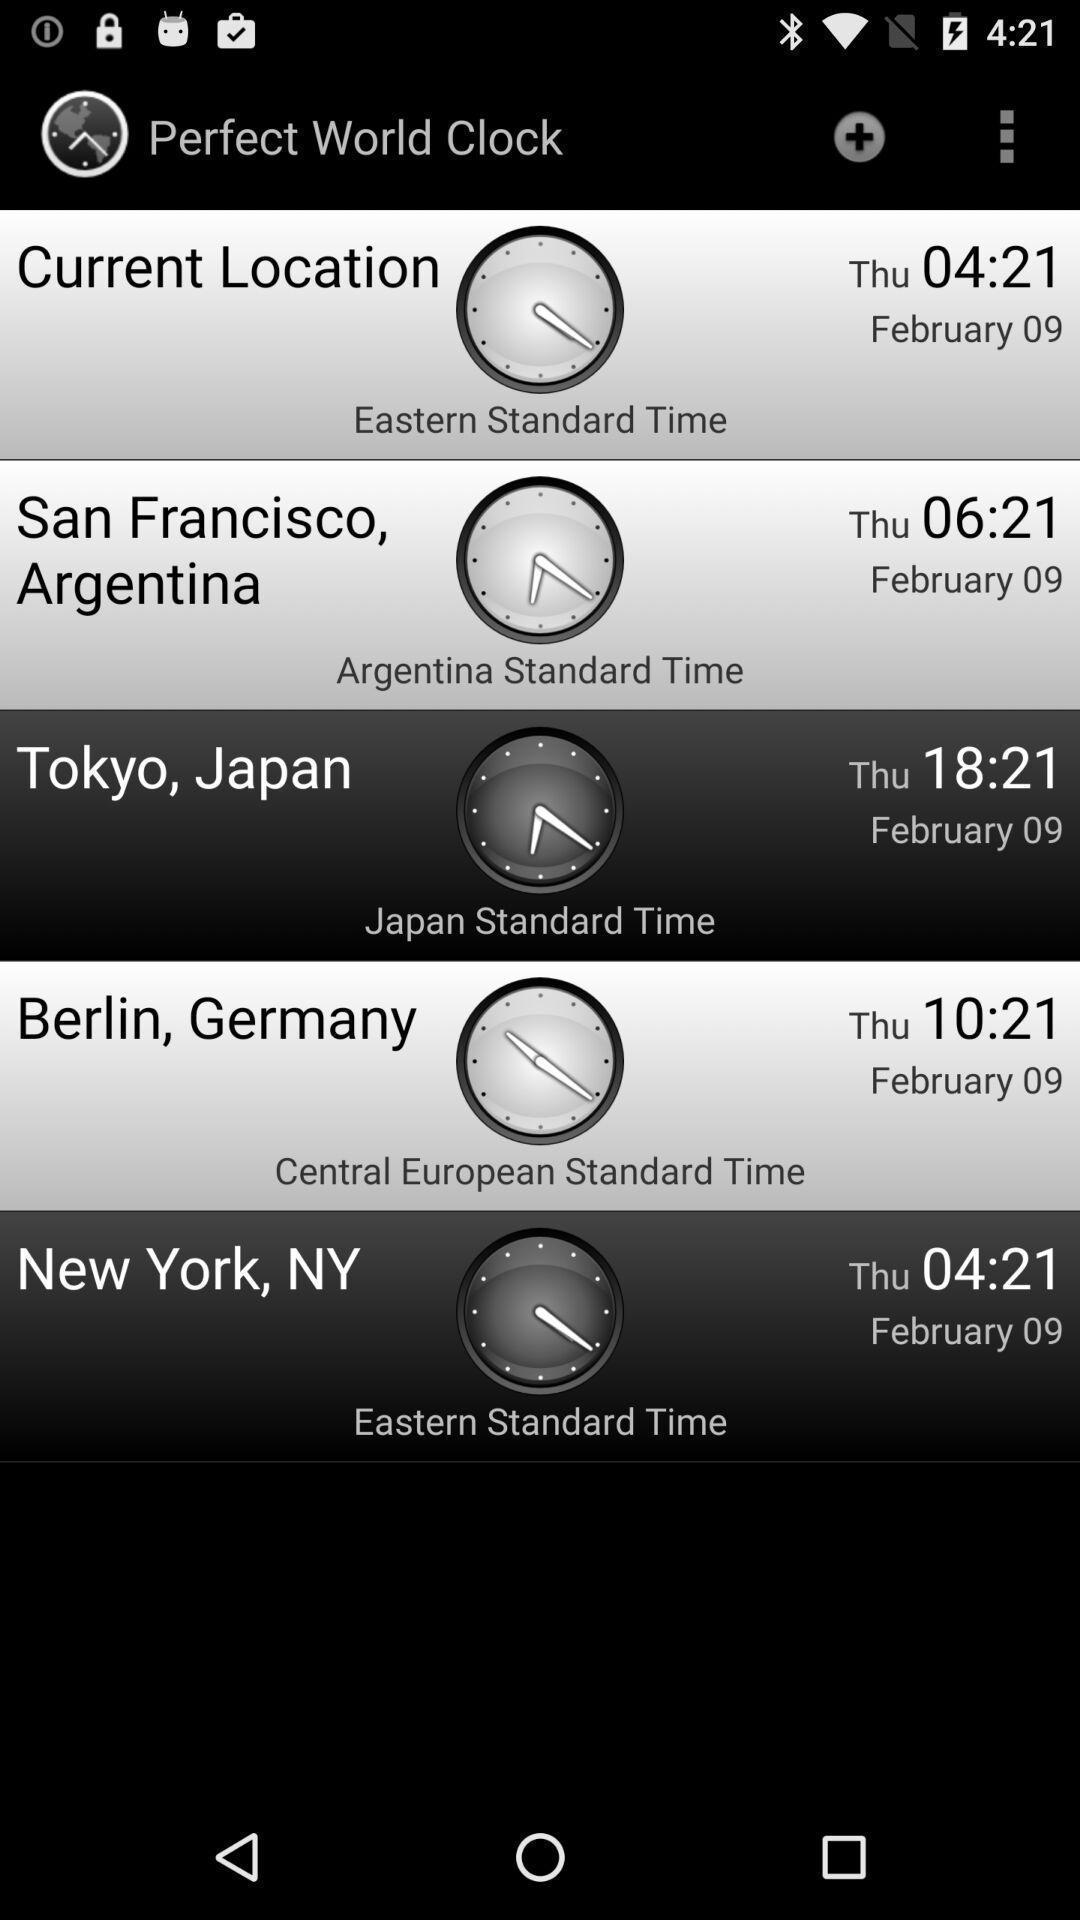Explain what's happening in this screen capture. Page shows details of perfect world clock. 